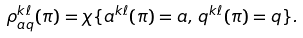<formula> <loc_0><loc_0><loc_500><loc_500>\rho ^ { k \ell } _ { a q } ( \pi ) = \chi \{ a ^ { k \ell } ( \pi ) = a , \, q ^ { k \ell } ( \pi ) = q \} .</formula> 